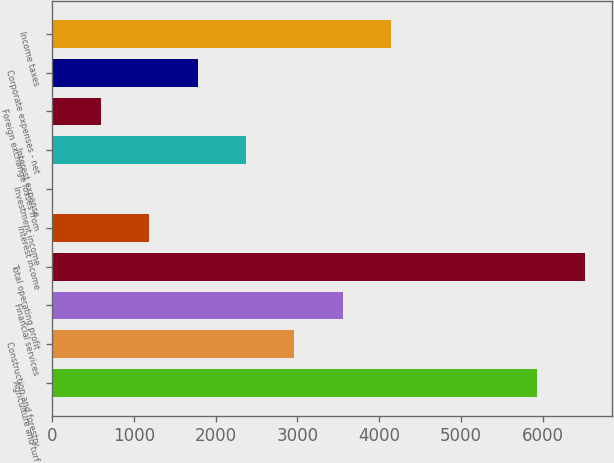<chart> <loc_0><loc_0><loc_500><loc_500><bar_chart><fcel>Agriculture and turf<fcel>Construction and forestry<fcel>Financial services<fcel>Total operating profit<fcel>Interest income<fcel>Investment income<fcel>Interest expense<fcel>Foreign exchange losses from<fcel>Corporate expenses - net<fcel>Income taxes<nl><fcel>5928<fcel>2965<fcel>3557.6<fcel>6520.6<fcel>1187.2<fcel>2<fcel>2372.4<fcel>594.6<fcel>1779.8<fcel>4150.2<nl></chart> 